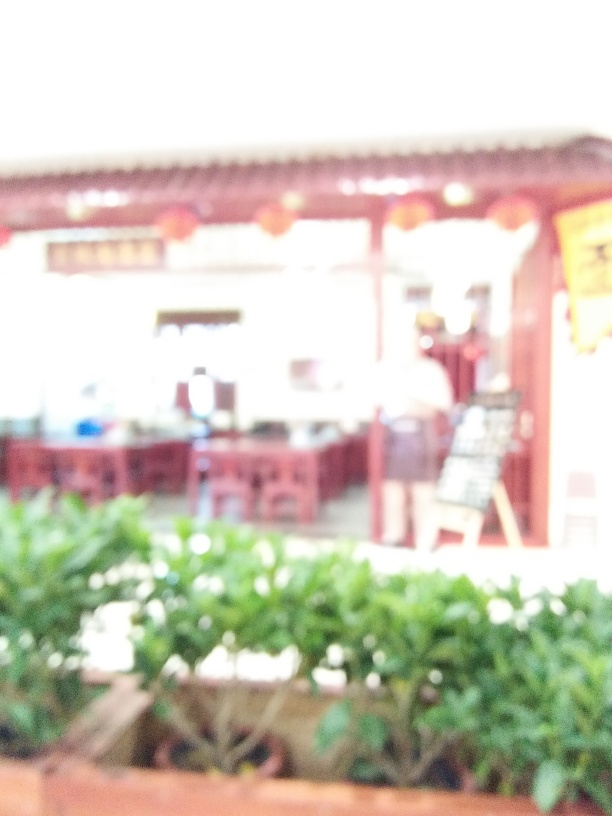What is the general mood or atmosphere this image could convey? Although the specific details are obscured, the bright light and soft focus convey a dreamy or nostalgic quality, possibly suggesting a memory or a scene from a warm, tranquil day. 